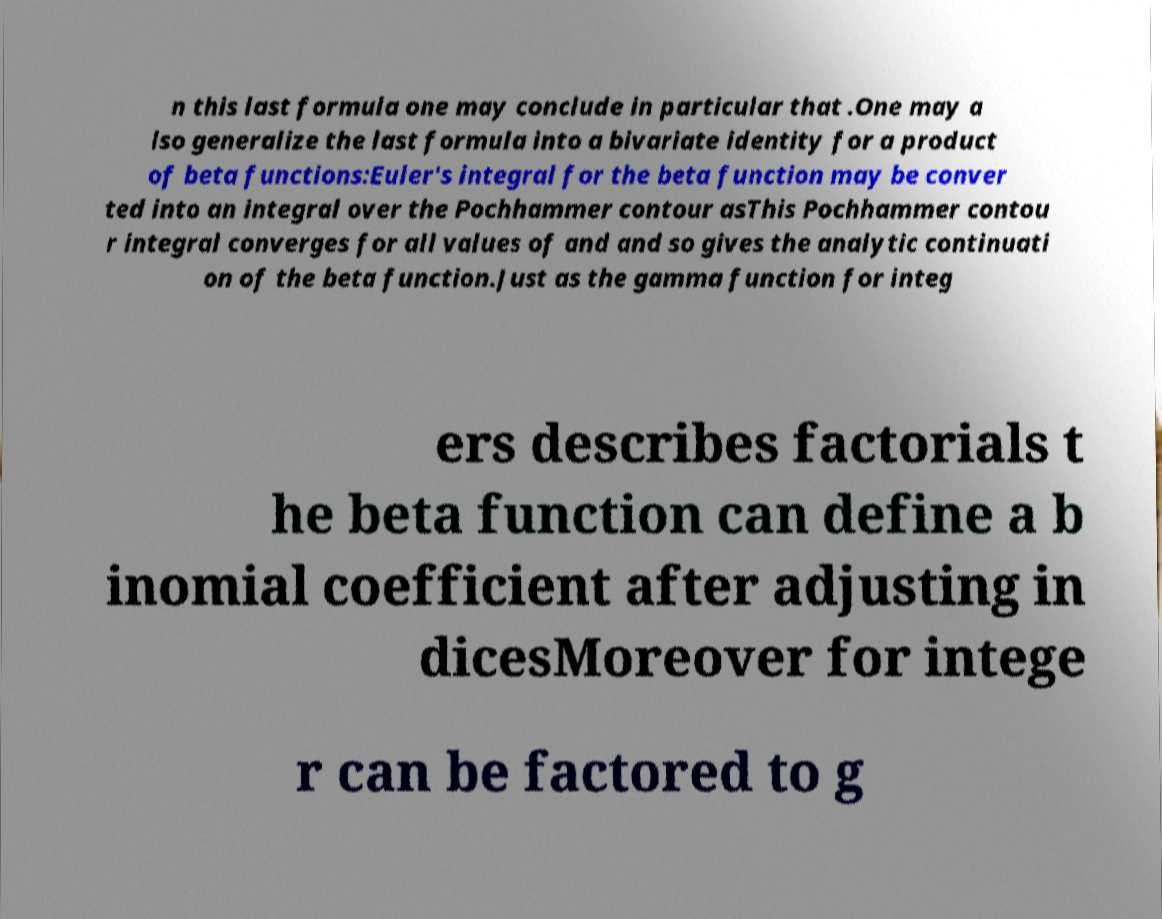Can you read and provide the text displayed in the image?This photo seems to have some interesting text. Can you extract and type it out for me? n this last formula one may conclude in particular that .One may a lso generalize the last formula into a bivariate identity for a product of beta functions:Euler's integral for the beta function may be conver ted into an integral over the Pochhammer contour asThis Pochhammer contou r integral converges for all values of and and so gives the analytic continuati on of the beta function.Just as the gamma function for integ ers describes factorials t he beta function can define a b inomial coefficient after adjusting in dicesMoreover for intege r can be factored to g 